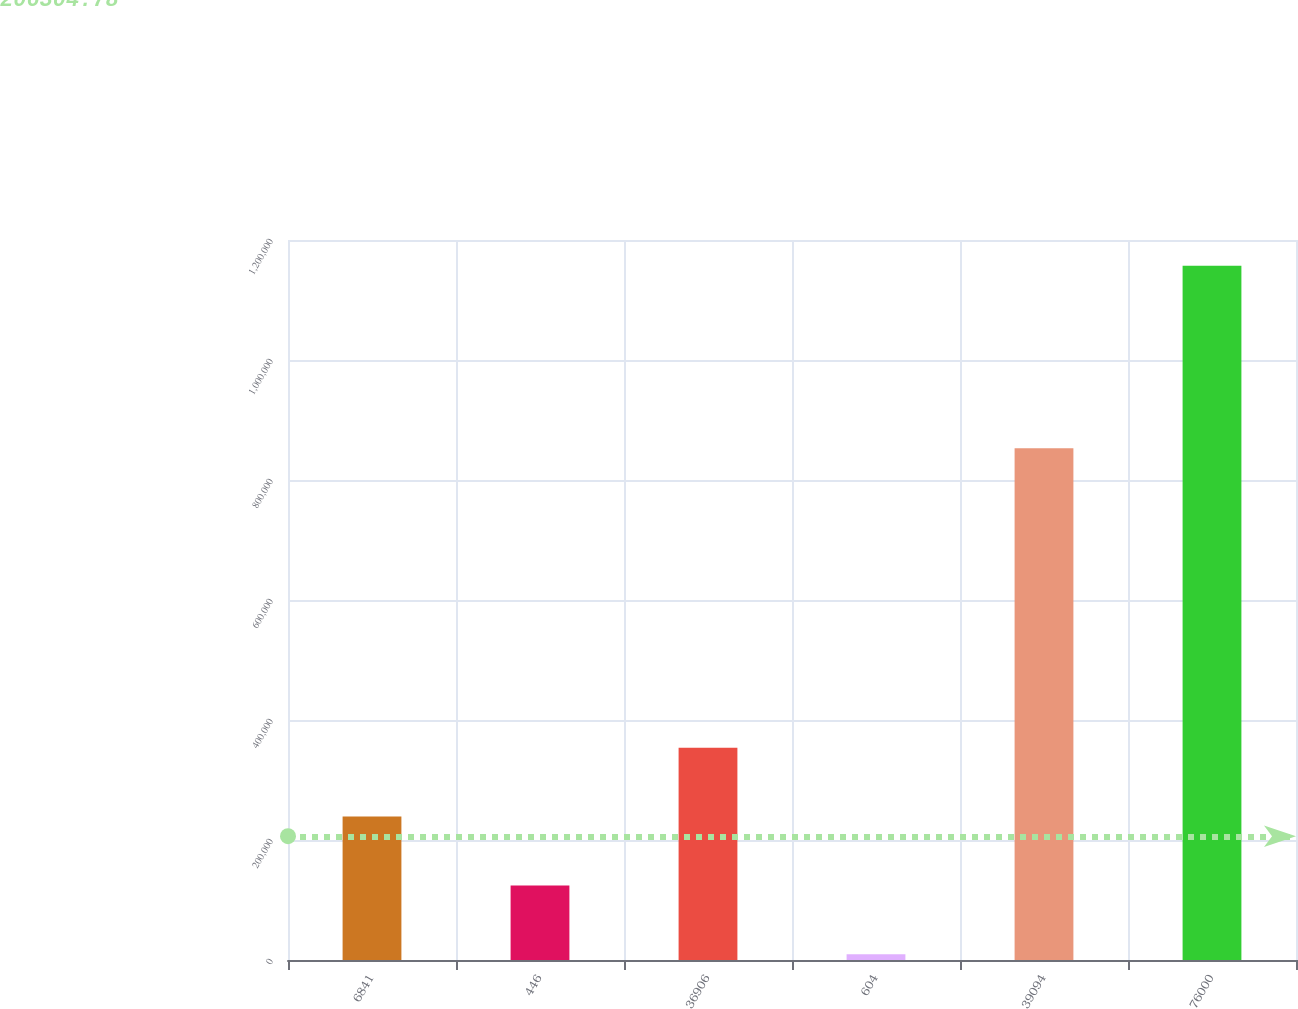Convert chart. <chart><loc_0><loc_0><loc_500><loc_500><bar_chart><fcel>6841<fcel>446<fcel>36906<fcel>604<fcel>39094<fcel>76000<nl><fcel>239033<fcel>124252<fcel>353813<fcel>9472<fcel>852721<fcel>1.15728e+06<nl></chart> 